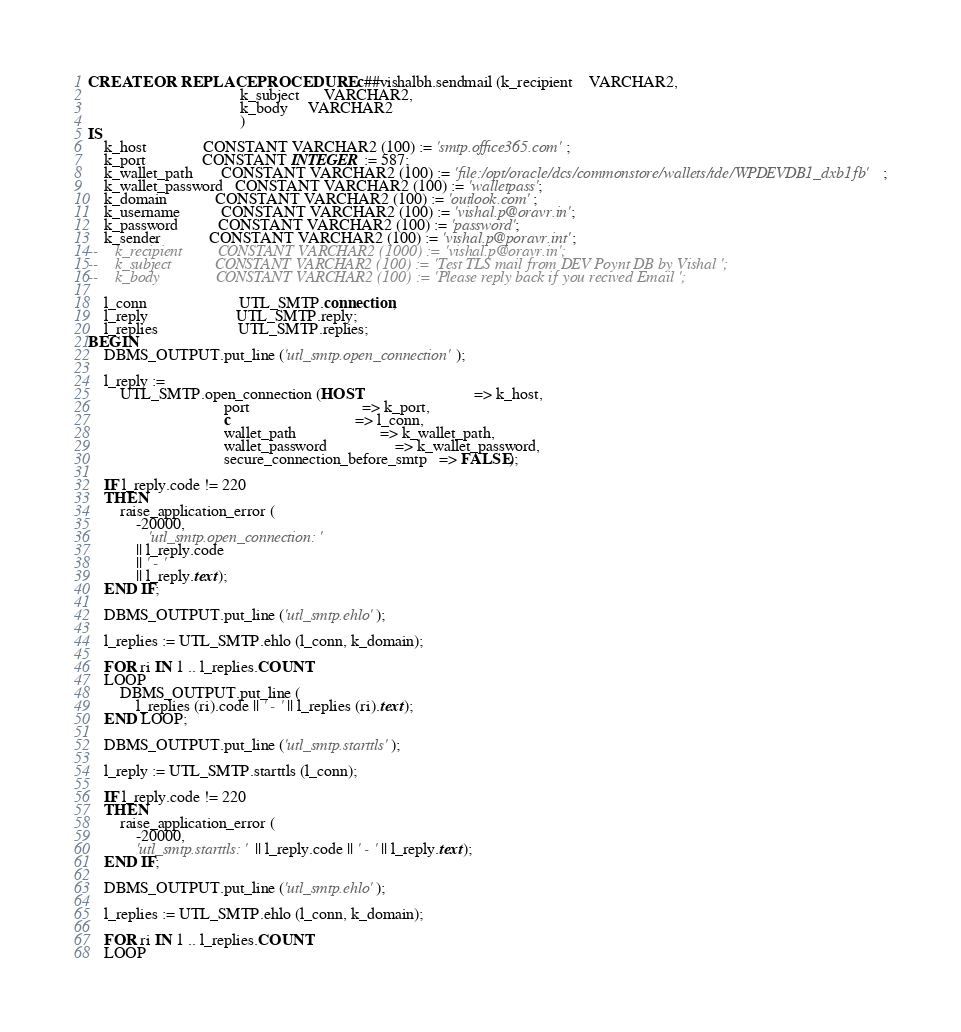<code> <loc_0><loc_0><loc_500><loc_500><_SQL_>
CREATE OR REPLACE PROCEDURE c##vishalbh.sendmail (k_recipient    VARCHAR2,
                                      k_subject      VARCHAR2,
                                      k_body     VARCHAR2
                                      )
IS
    k_host              CONSTANT VARCHAR2 (100) := 'smtp.office365.com';
    k_port              CONSTANT INTEGER := 587;
    k_wallet_path       CONSTANT VARCHAR2 (100) := 'file:/opt/oracle/dcs/commonstore/wallets/tde/WPDEVDB1_dxb1fb';
    k_wallet_password   CONSTANT VARCHAR2 (100) := 'walletpass';
    k_domain            CONSTANT VARCHAR2 (100) := 'outlook.com';
    k_username          CONSTANT VARCHAR2 (100) := 'vishal.p@oravr.in';
    k_password          CONSTANT VARCHAR2 (100) := 'password';
    k_sender            CONSTANT VARCHAR2 (100) := 'vishal.p@poravr.int';
--    k_recipient         CONSTANT VARCHAR2 (1000) := 'vishal.p@oravr.in';
--    k_subject           CONSTANT VARCHAR2 (100) := 'Test TLS mail from DEV Poynt DB by Vishal ';
--    k_body              CONSTANT VARCHAR2 (100) := 'Please reply back if you recived Email ';

    l_conn                       UTL_SMTP.connection;
    l_reply                      UTL_SMTP.reply;
    l_replies                    UTL_SMTP.replies;
BEGIN
    DBMS_OUTPUT.put_line ('utl_smtp.open_connection');

    l_reply :=
        UTL_SMTP.open_connection (HOST                            => k_host,
                                  port                            => k_port,
                                  c                               => l_conn,
                                  wallet_path                     => k_wallet_path,
                                  wallet_password                 => k_wallet_password,
                                  secure_connection_before_smtp   => FALSE);

    IF l_reply.code != 220
    THEN
        raise_application_error (
            -20000,
               'utl_smtp.open_connection: '
            || l_reply.code
            || ' - '
            || l_reply.text);
    END IF;

    DBMS_OUTPUT.put_line ('utl_smtp.ehlo');

    l_replies := UTL_SMTP.ehlo (l_conn, k_domain);

    FOR ri IN 1 .. l_replies.COUNT
    LOOP
        DBMS_OUTPUT.put_line (
            l_replies (ri).code || ' - ' || l_replies (ri).text);
    END LOOP;

    DBMS_OUTPUT.put_line ('utl_smtp.starttls');

    l_reply := UTL_SMTP.starttls (l_conn);

    IF l_reply.code != 220
    THEN
        raise_application_error (
            -20000,
            'utl_smtp.starttls: ' || l_reply.code || ' - ' || l_reply.text);
    END IF;

    DBMS_OUTPUT.put_line ('utl_smtp.ehlo');

    l_replies := UTL_SMTP.ehlo (l_conn, k_domain);

    FOR ri IN 1 .. l_replies.COUNT
    LOOP</code> 